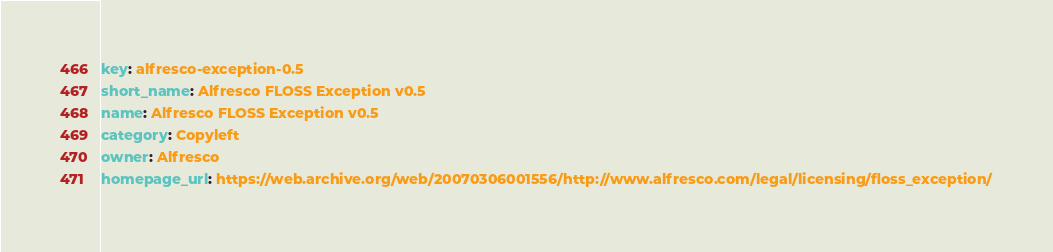<code> <loc_0><loc_0><loc_500><loc_500><_YAML_>key: alfresco-exception-0.5
short_name: Alfresco FLOSS Exception v0.5
name: Alfresco FLOSS Exception v0.5
category: Copyleft
owner: Alfresco
homepage_url: https://web.archive.org/web/20070306001556/http://www.alfresco.com/legal/licensing/floss_exception/
</code> 